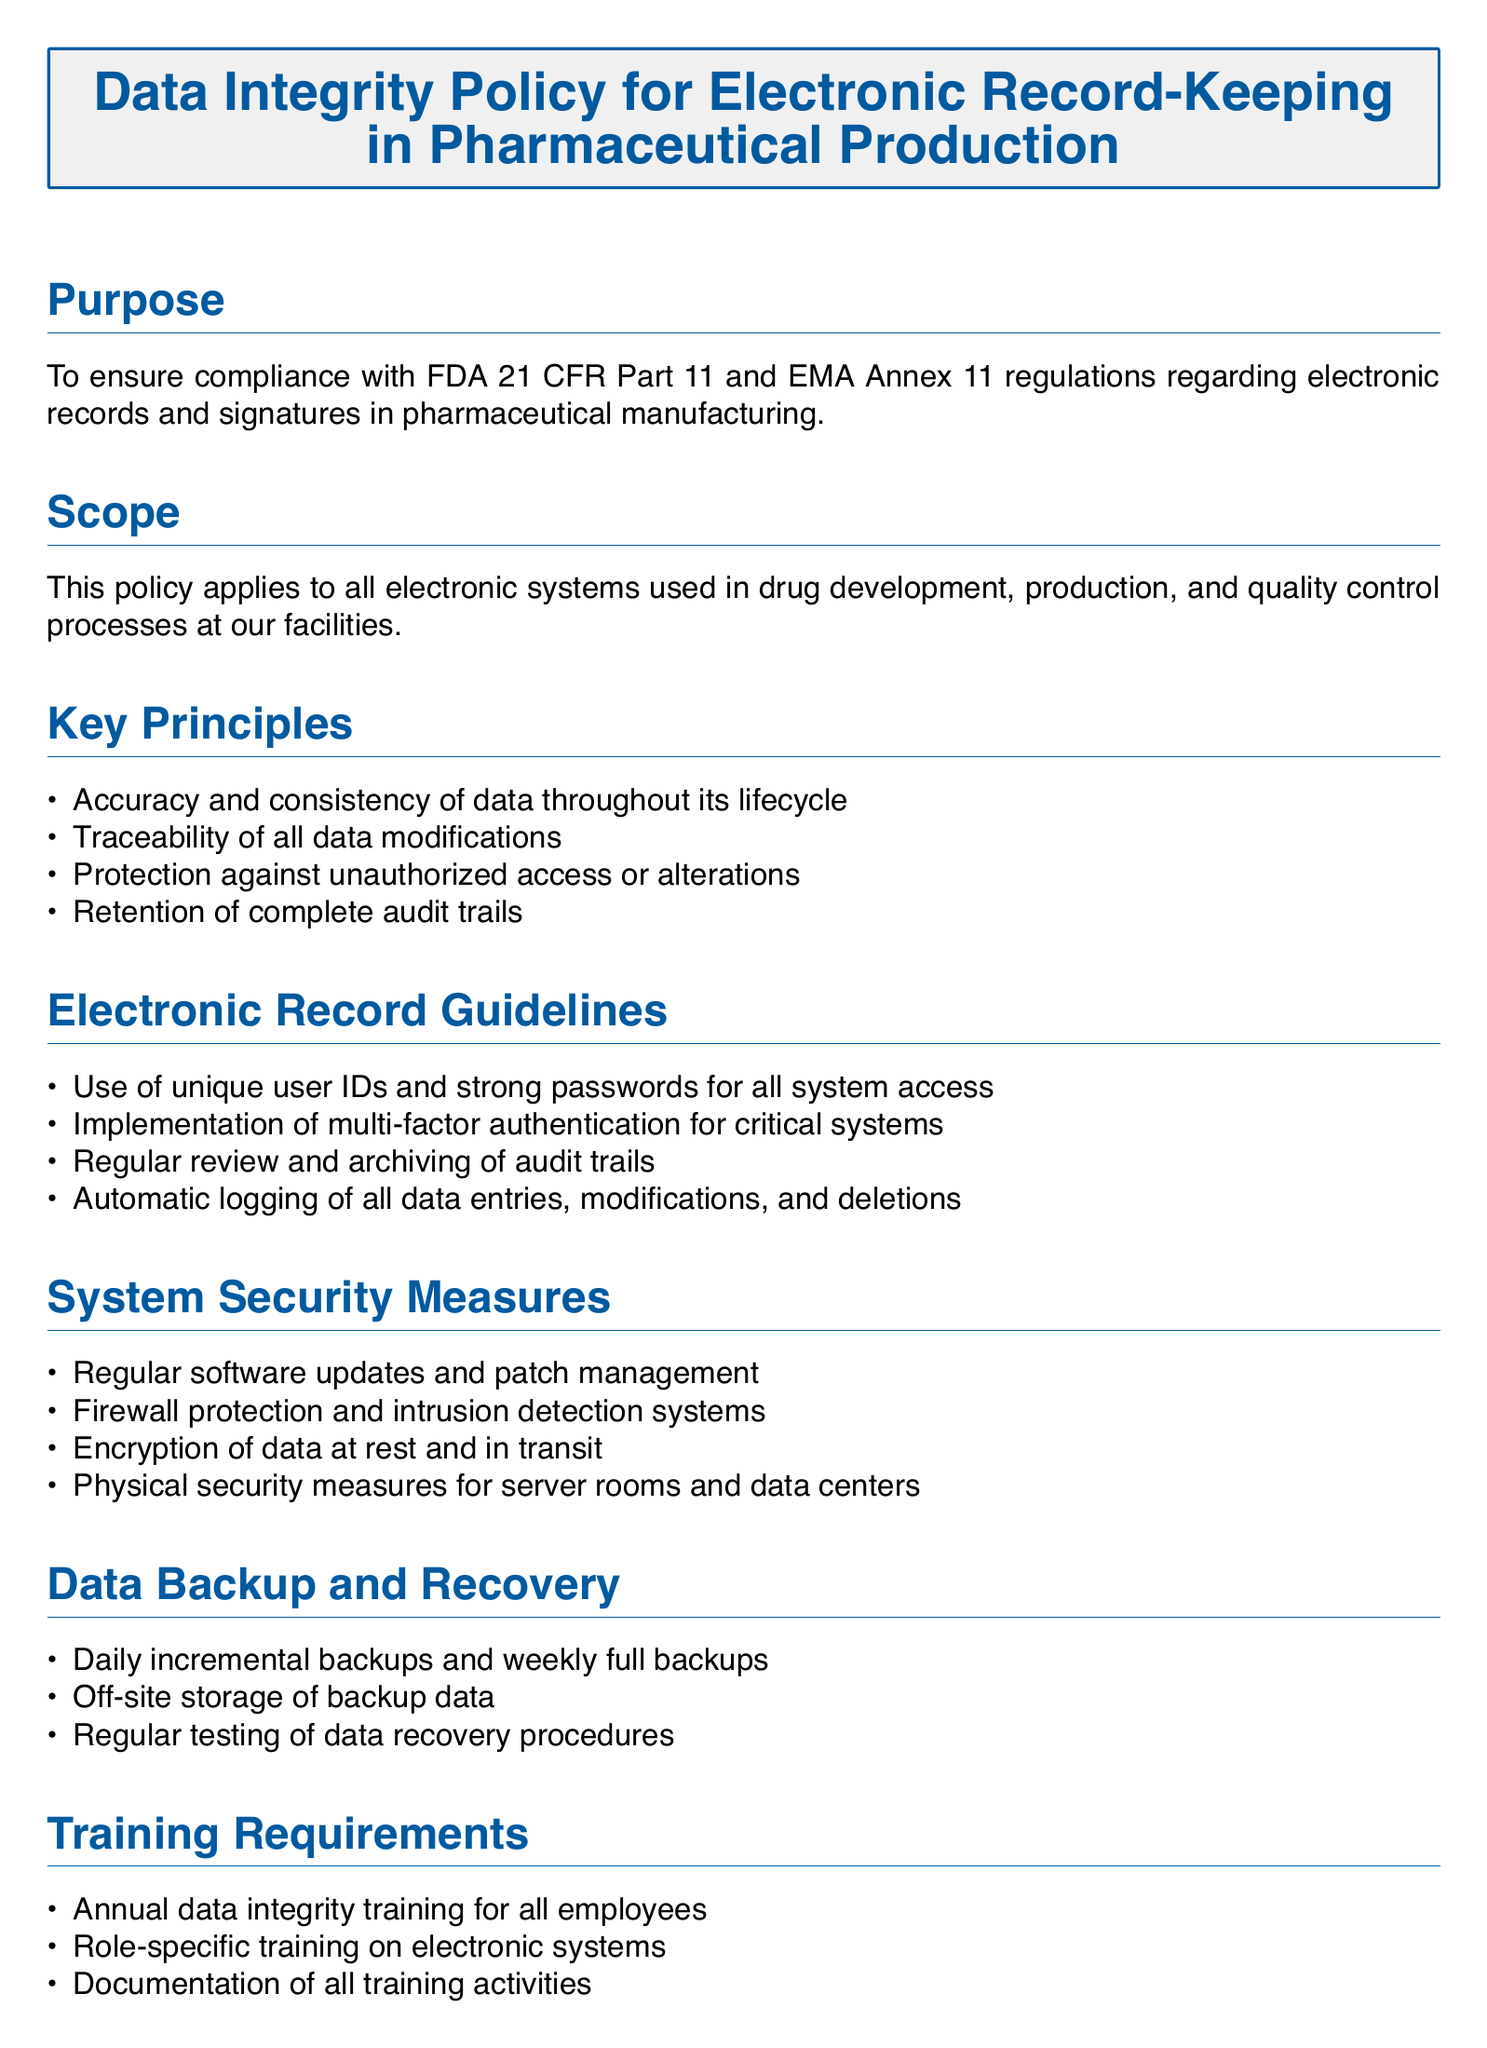What is the purpose of the Data Integrity Policy? The purpose of the policy is outlined in the document's Purpose section, ensuring compliance with FDA and EMA regulations regarding electronic records and signatures.
Answer: To ensure compliance with FDA 21 CFR Part 11 and EMA Annex 11 regulations regarding electronic records and signatures in pharmaceutical manufacturing What does the scope of the policy apply to? The Scope section specifies the areas the policy covers, detailing the electronic systems involved in pharmaceutical processes.
Answer: All electronic systems used in drug development, production, and quality control processes at our facilities What is one key principle mentioned in the document? Key principles outlined in the document provide a framework for data integrity throughout its lifecycle.
Answer: Protection against unauthorized access or alterations How often are internal audits conducted? The Compliance Monitoring section mentions the frequency of internal audits and assessments to ensure compliance.
Answer: Regular internal audits What type of backups are implemented according to the policy? The Data Backup and Recovery section provides details on the types of backups used to protect data.
Answer: Daily incremental backups and weekly full backups What is required for system access? The Electronic Record Guidelines section specifies security measures required for accessing systems.
Answer: Use of unique user IDs and strong passwords for all system access What kind of training is required for employees? The Training Requirements section lists the mandatory training programs employees must complete to ensure data integrity awareness.
Answer: Annual data integrity training for all employees What is the review cycle for this policy? The document outlines how often the policy is reviewed and updated, ensuring its relevance and compliance.
Answer: Annual review and update of this policy by the Quality Assurance department 